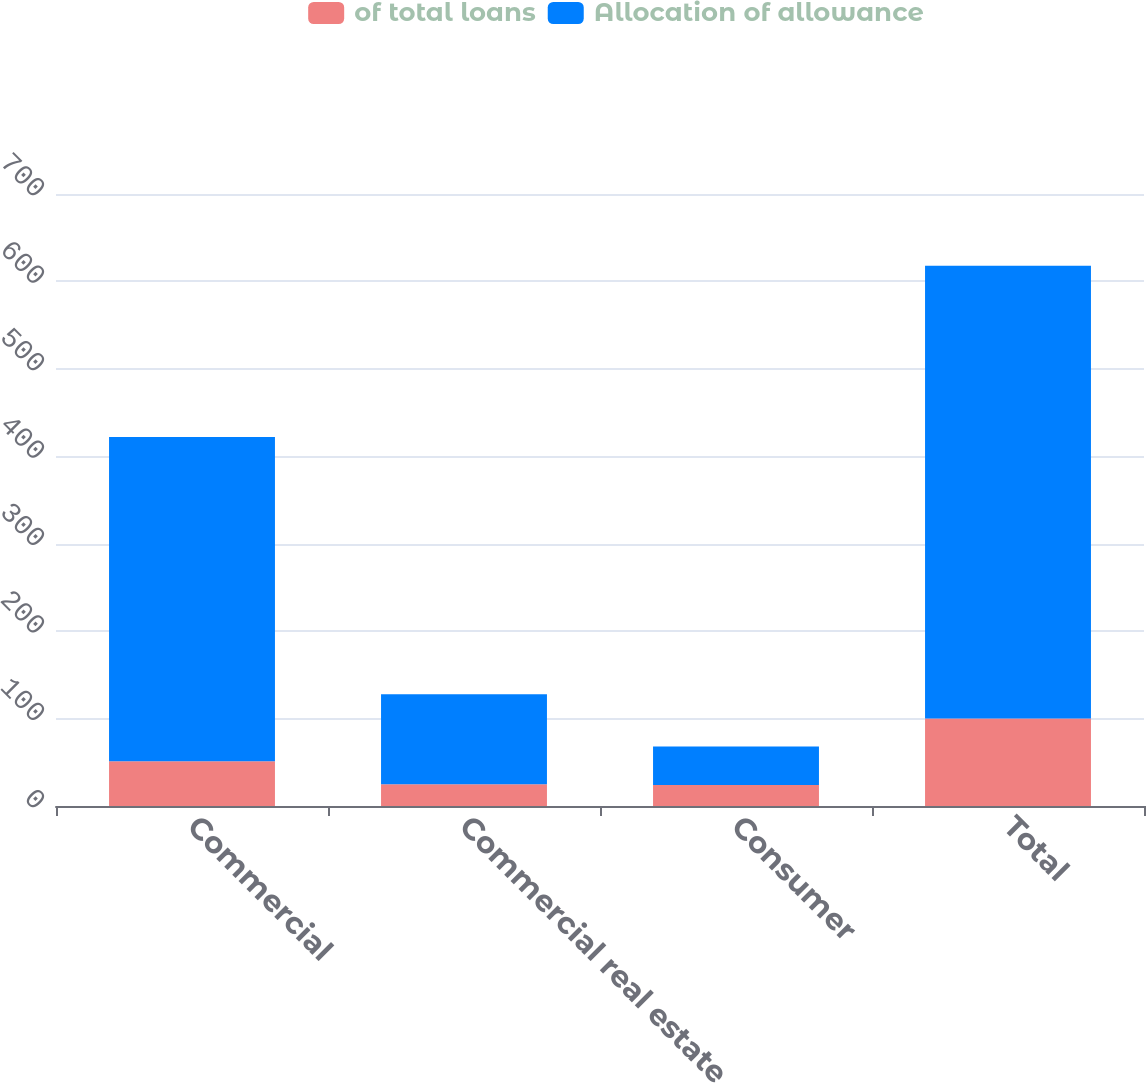Convert chart. <chart><loc_0><loc_0><loc_500><loc_500><stacked_bar_chart><ecel><fcel>Commercial<fcel>Commercial real estate<fcel>Consumer<fcel>Total<nl><fcel>of total loans<fcel>51.2<fcel>24.8<fcel>24<fcel>100<nl><fcel>Allocation of allowance<fcel>371<fcel>103<fcel>44<fcel>518<nl></chart> 